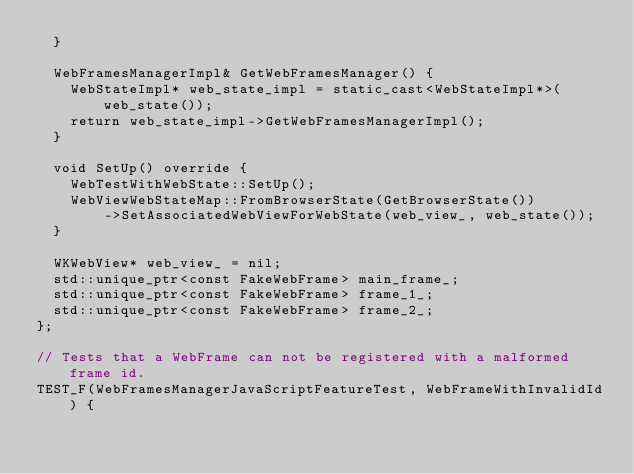Convert code to text. <code><loc_0><loc_0><loc_500><loc_500><_ObjectiveC_>  }

  WebFramesManagerImpl& GetWebFramesManager() {
    WebStateImpl* web_state_impl = static_cast<WebStateImpl*>(web_state());
    return web_state_impl->GetWebFramesManagerImpl();
  }

  void SetUp() override {
    WebTestWithWebState::SetUp();
    WebViewWebStateMap::FromBrowserState(GetBrowserState())
        ->SetAssociatedWebViewForWebState(web_view_, web_state());
  }

  WKWebView* web_view_ = nil;
  std::unique_ptr<const FakeWebFrame> main_frame_;
  std::unique_ptr<const FakeWebFrame> frame_1_;
  std::unique_ptr<const FakeWebFrame> frame_2_;
};

// Tests that a WebFrame can not be registered with a malformed frame id.
TEST_F(WebFramesManagerJavaScriptFeatureTest, WebFrameWithInvalidId) {</code> 